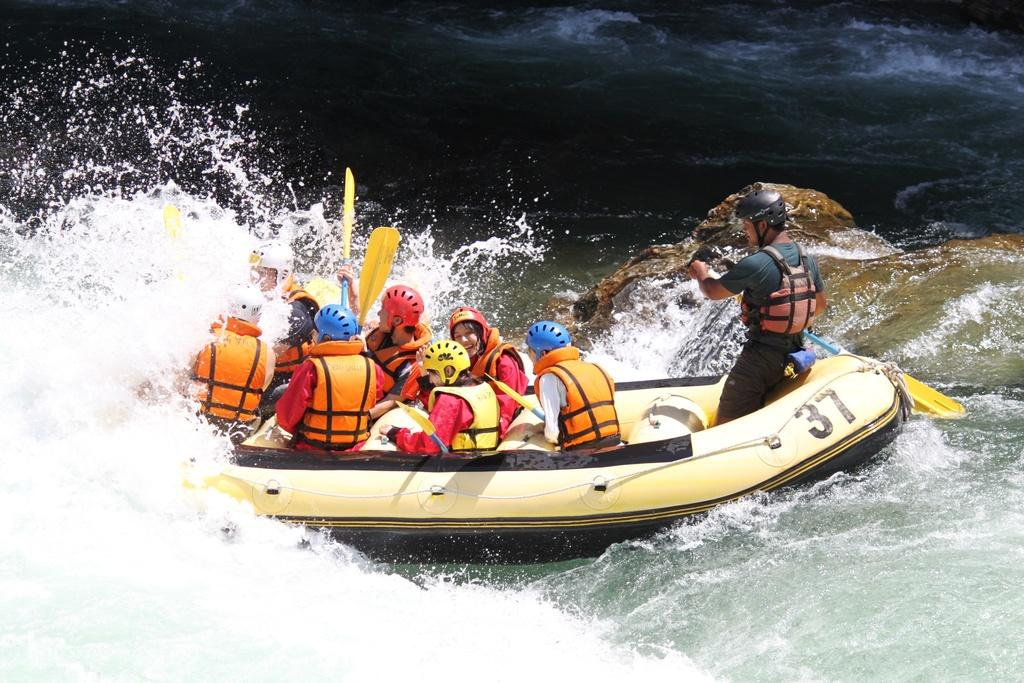How many people are in the image? There are persons in the image. What activity are the persons engaged in? The persons are rafting. Where is the rafting taking place? The rafting is taking place in water. What type of acoustics can be heard in the image? There is no information about acoustics in the image, as it focuses on people rafting in water. 